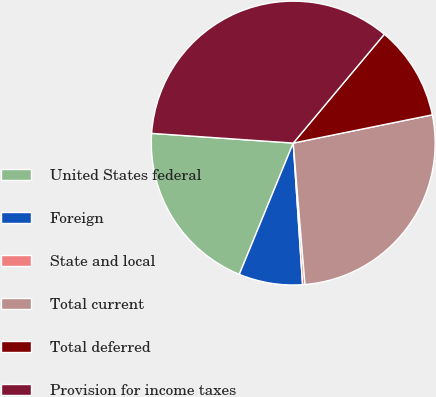Convert chart. <chart><loc_0><loc_0><loc_500><loc_500><pie_chart><fcel>United States federal<fcel>Foreign<fcel>State and local<fcel>Total current<fcel>Total deferred<fcel>Provision for income taxes<nl><fcel>19.89%<fcel>7.25%<fcel>0.27%<fcel>26.87%<fcel>10.72%<fcel>35.0%<nl></chart> 